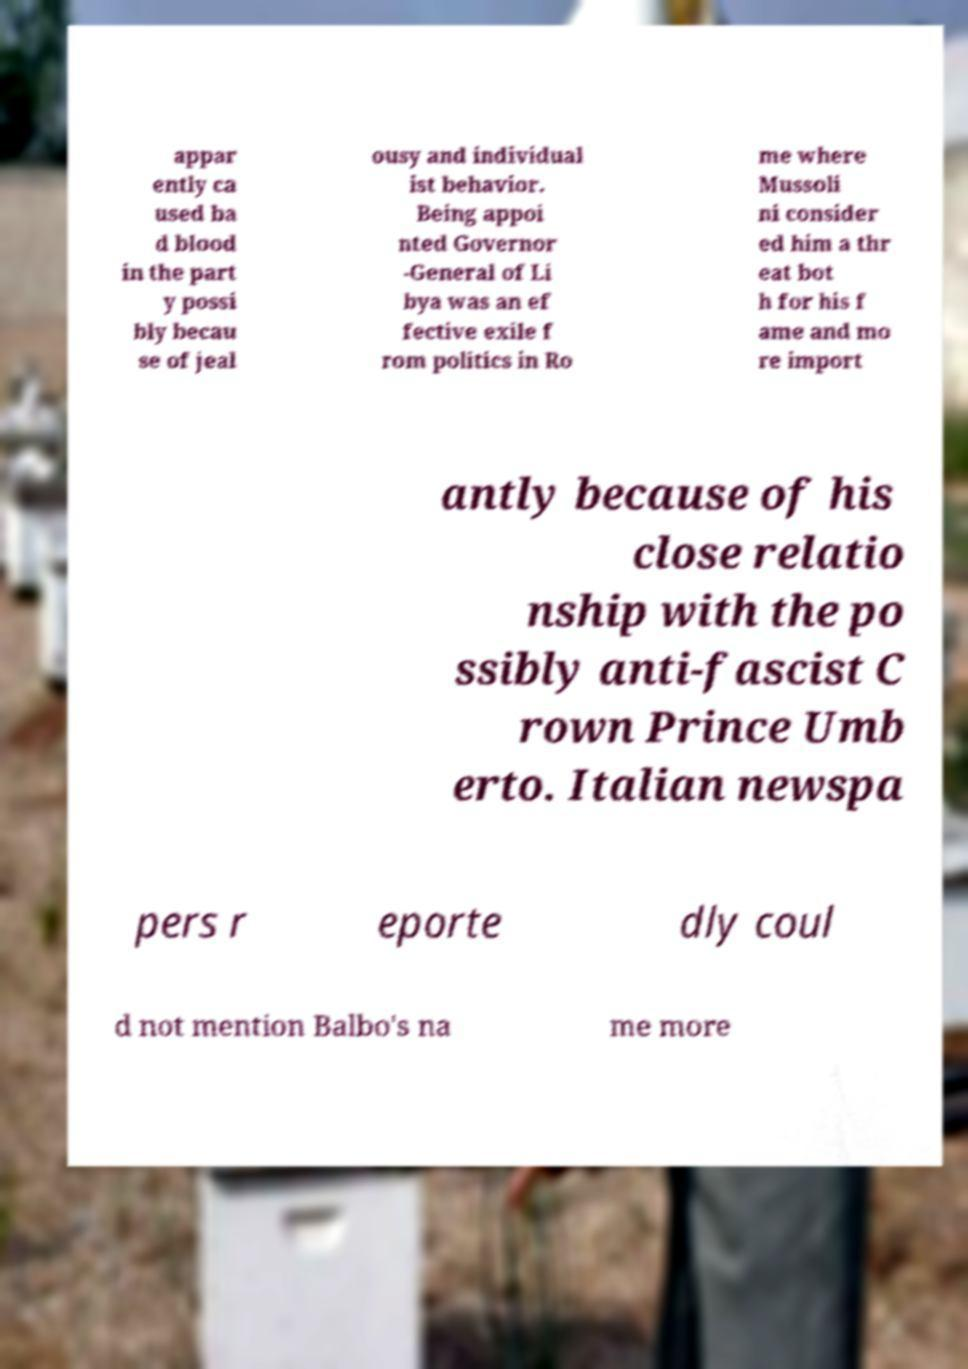Could you extract and type out the text from this image? appar ently ca used ba d blood in the part y possi bly becau se of jeal ousy and individual ist behavior. Being appoi nted Governor -General of Li bya was an ef fective exile f rom politics in Ro me where Mussoli ni consider ed him a thr eat bot h for his f ame and mo re import antly because of his close relatio nship with the po ssibly anti-fascist C rown Prince Umb erto. Italian newspa pers r eporte dly coul d not mention Balbo's na me more 